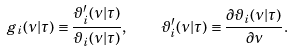Convert formula to latex. <formula><loc_0><loc_0><loc_500><loc_500>g _ { i } ( \nu | \tau ) \equiv \frac { \vartheta _ { i } ^ { \prime } ( \nu | \tau ) } { \vartheta _ { i } ( \nu | \tau ) } , \quad \vartheta _ { i } ^ { \prime } ( \nu | \tau ) \equiv \frac { \partial \vartheta _ { i } ( \nu | \tau ) } { \partial \nu } .</formula> 